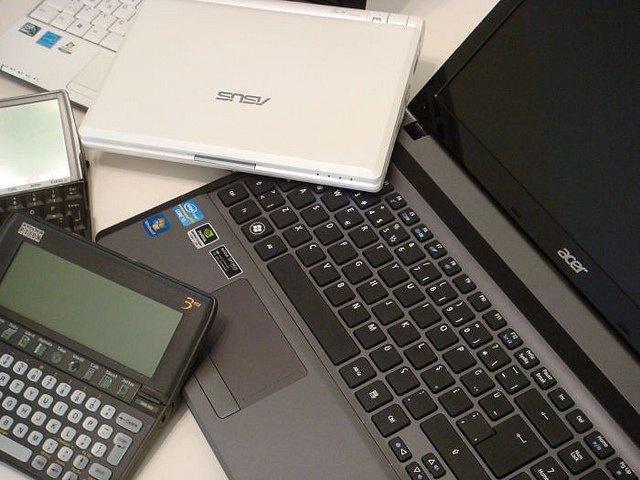Describe the objects in this image and their specific colors. I can see laptop in tan, black, and gray tones, keyboard in tan, black, and gray tones, laptop in tan, lightgray, darkgray, and gray tones, keyboard in tan, darkgray, gray, and black tones, and laptop in tan, lightgray, and darkgray tones in this image. 